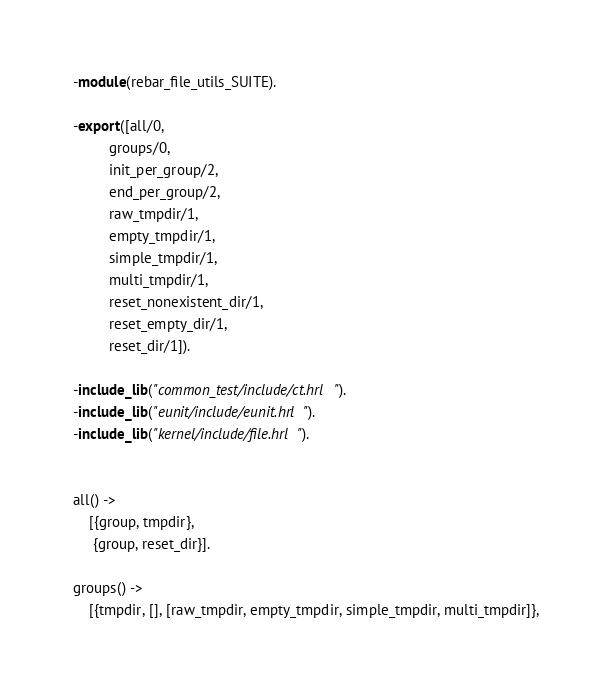<code> <loc_0><loc_0><loc_500><loc_500><_Erlang_>-module(rebar_file_utils_SUITE).

-export([all/0,
         groups/0,
         init_per_group/2,
         end_per_group/2,
         raw_tmpdir/1,
         empty_tmpdir/1,
         simple_tmpdir/1,
         multi_tmpdir/1,
         reset_nonexistent_dir/1,
         reset_empty_dir/1,
         reset_dir/1]).

-include_lib("common_test/include/ct.hrl").
-include_lib("eunit/include/eunit.hrl").
-include_lib("kernel/include/file.hrl").


all() ->
    [{group, tmpdir},
     {group, reset_dir}].

groups() ->
    [{tmpdir, [], [raw_tmpdir, empty_tmpdir, simple_tmpdir, multi_tmpdir]},</code> 